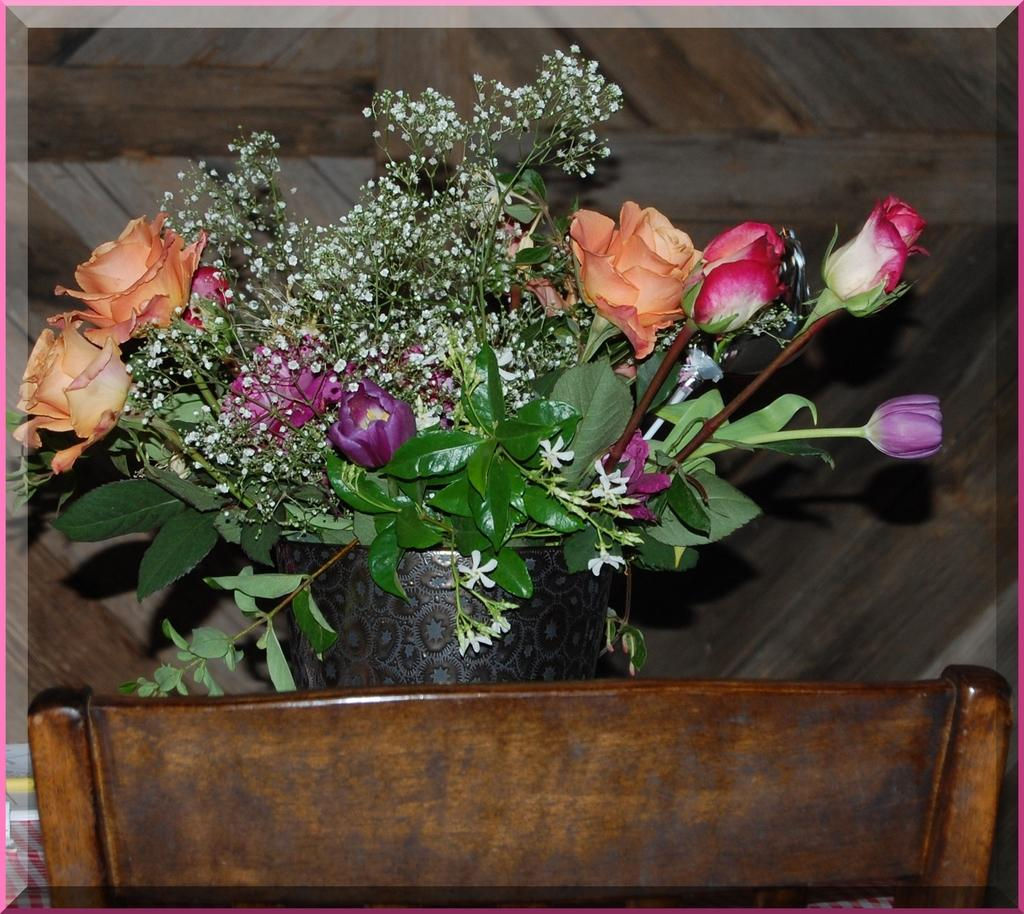What type of living organisms can be seen in the image? There are flowers and a plant in the image. How is the plant situated in the image? The plant is in a pot in the image. What type of furniture is present in the image? There is a chair in the image. What type of rock is being played as an instrument in the image? There is no rock or instrument present in the image; it features flowers, a plant in a pot, and a chair. 